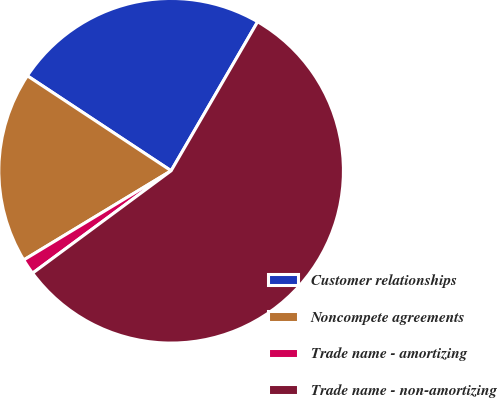Convert chart. <chart><loc_0><loc_0><loc_500><loc_500><pie_chart><fcel>Customer relationships<fcel>Noncompete agreements<fcel>Trade name - amortizing<fcel>Trade name - non-amortizing<nl><fcel>24.08%<fcel>17.95%<fcel>1.47%<fcel>56.5%<nl></chart> 